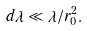Convert formula to latex. <formula><loc_0><loc_0><loc_500><loc_500>d \lambda \ll \lambda / r _ { 0 } ^ { 2 } .</formula> 